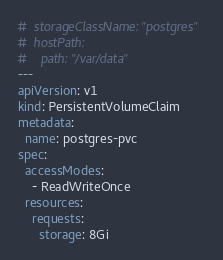<code> <loc_0><loc_0><loc_500><loc_500><_YAML_>#  storageClassName: "postgres"
#  hostPath:
#    path: "/var/data"
---
apiVersion: v1
kind: PersistentVolumeClaim
metadata:
  name: postgres-pvc
spec:
  accessModes:
    - ReadWriteOnce
  resources:
    requests:
      storage: 8Gi
</code> 